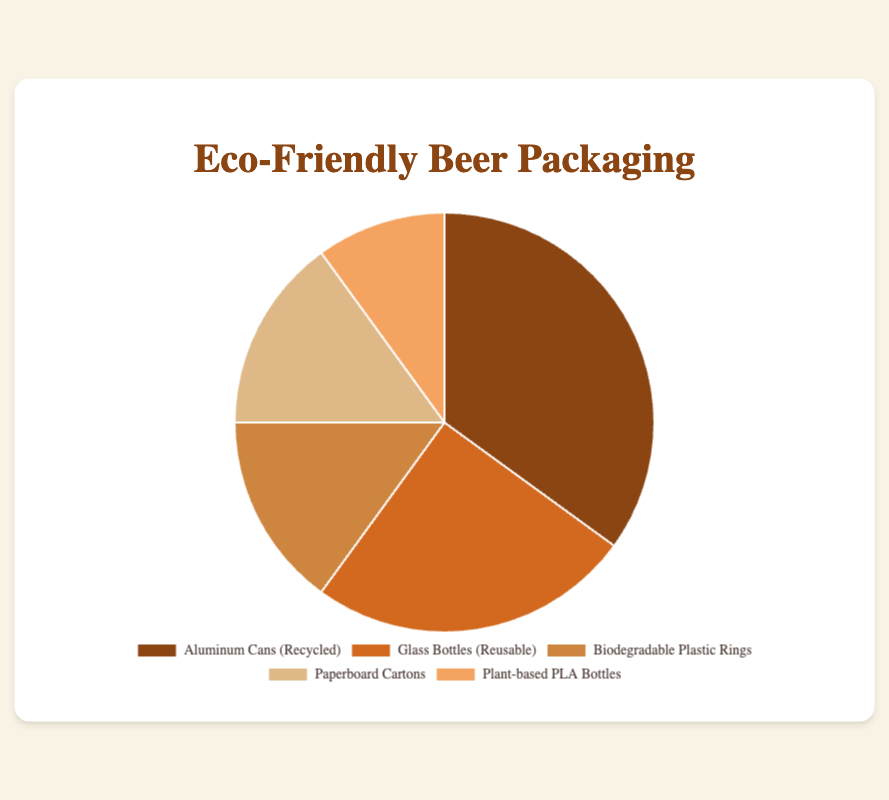Which type of eco-friendly packaging is used the most? From the pie chart, "Aluminum Cans (Recycled)" has the largest percentage (35%).
Answer: Aluminum Cans (Recycled) Which type of eco-friendly packaging is used the least? From the pie chart, "Plant-based PLA Bottles" has the smallest percentage (10%).
Answer: Plant-based PLA Bottles How much more popular are Aluminum Cans (Recycled) compared to Plant-based PLA Bottles? Aluminum Cans (Recycled) make up 35% while Plant-based PLA Bottles make up 10%. The difference is 35% - 10% = 25%.
Answer: 25% Do Biodegradable Plastic Rings and Paperboard Cartons combined make up more than Glass Bottles (Reusable)? Biodegradable Plastic Rings and Paperboard Cartons both have 15%, for a total of 15% + 15% = 30%. Glass Bottles (Reusable) have 25%. Since 30% > 25%, the answer is yes.
Answer: Yes What is the combined percentage of the two least popular types of packaging? The least popular types are Plant-based PLA Bottles (10%) and Biodegradable Plastic Rings (15%). Combined, they make up 10% + 15% = 25%.
Answer: 25% Which two types of eco-friendly packaging together make up 50% of the chart? Aluminum Cans (Recycled) make up 35%, and Glass Bottles (Reusable) make up 25%. Together, they add up to 35% + 25% = 60%. Since we're looking for 50%, the combination of Biodegradable Plastic Rings (15%) and Paperboard Cartons (15%) can be ruled out. The correct combination is Aluminum Cans (Recycled) and Glass Bottles (Reusable).
Answer: Aluminum Cans (Recycled) and Glass Bottles (Reusable) What is the total percentage for all five types of eco-friendly packaging? All percentages should add up to 100% because they are parts of a whole pie chart.
Answer: 100% Do more than half of the packagings use either Aluminum Cans (Recycled) or Glass Bottles (Reusable)? Aluminum Cans (Recycled) are 35% and Glass Bottles (Reusable) are 25%. Together, they make up 35% + 25% = 60%, which is more than 50%.
Answer: Yes 